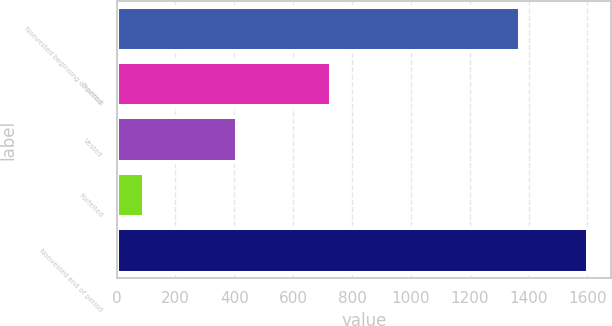<chart> <loc_0><loc_0><loc_500><loc_500><bar_chart><fcel>Nonvested beginning of period<fcel>Granted<fcel>Vested<fcel>Forfeited<fcel>Nonvested end of period<nl><fcel>1371<fcel>730<fcel>408<fcel>92<fcel>1601<nl></chart> 